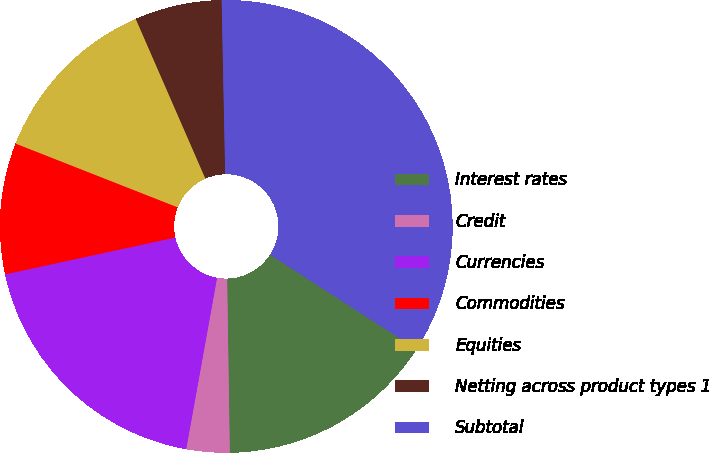Convert chart. <chart><loc_0><loc_0><loc_500><loc_500><pie_chart><fcel>Interest rates<fcel>Credit<fcel>Currencies<fcel>Commodities<fcel>Equities<fcel>Netting across product types 1<fcel>Subtotal<nl><fcel>15.63%<fcel>3.08%<fcel>18.77%<fcel>9.36%<fcel>12.49%<fcel>6.22%<fcel>34.45%<nl></chart> 